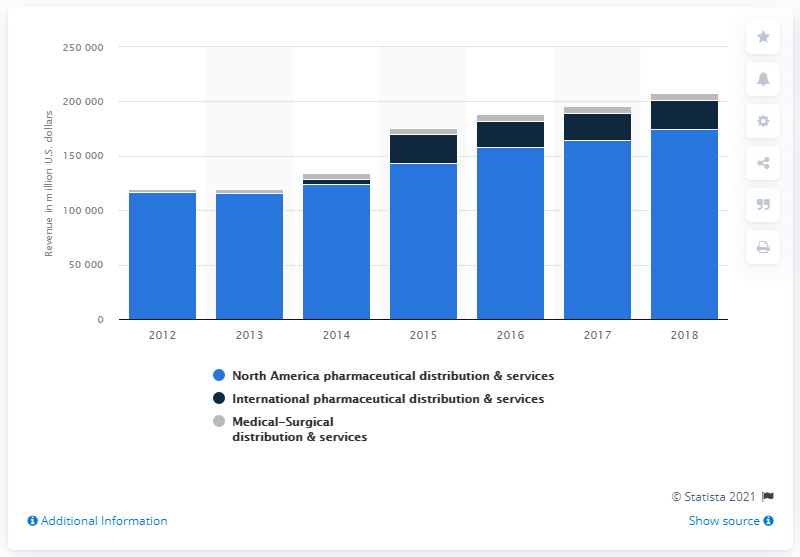Outline some significant characteristics in this image. In 2018, the total revenue in the medical-surgical distribution and services segment was 6,611. 